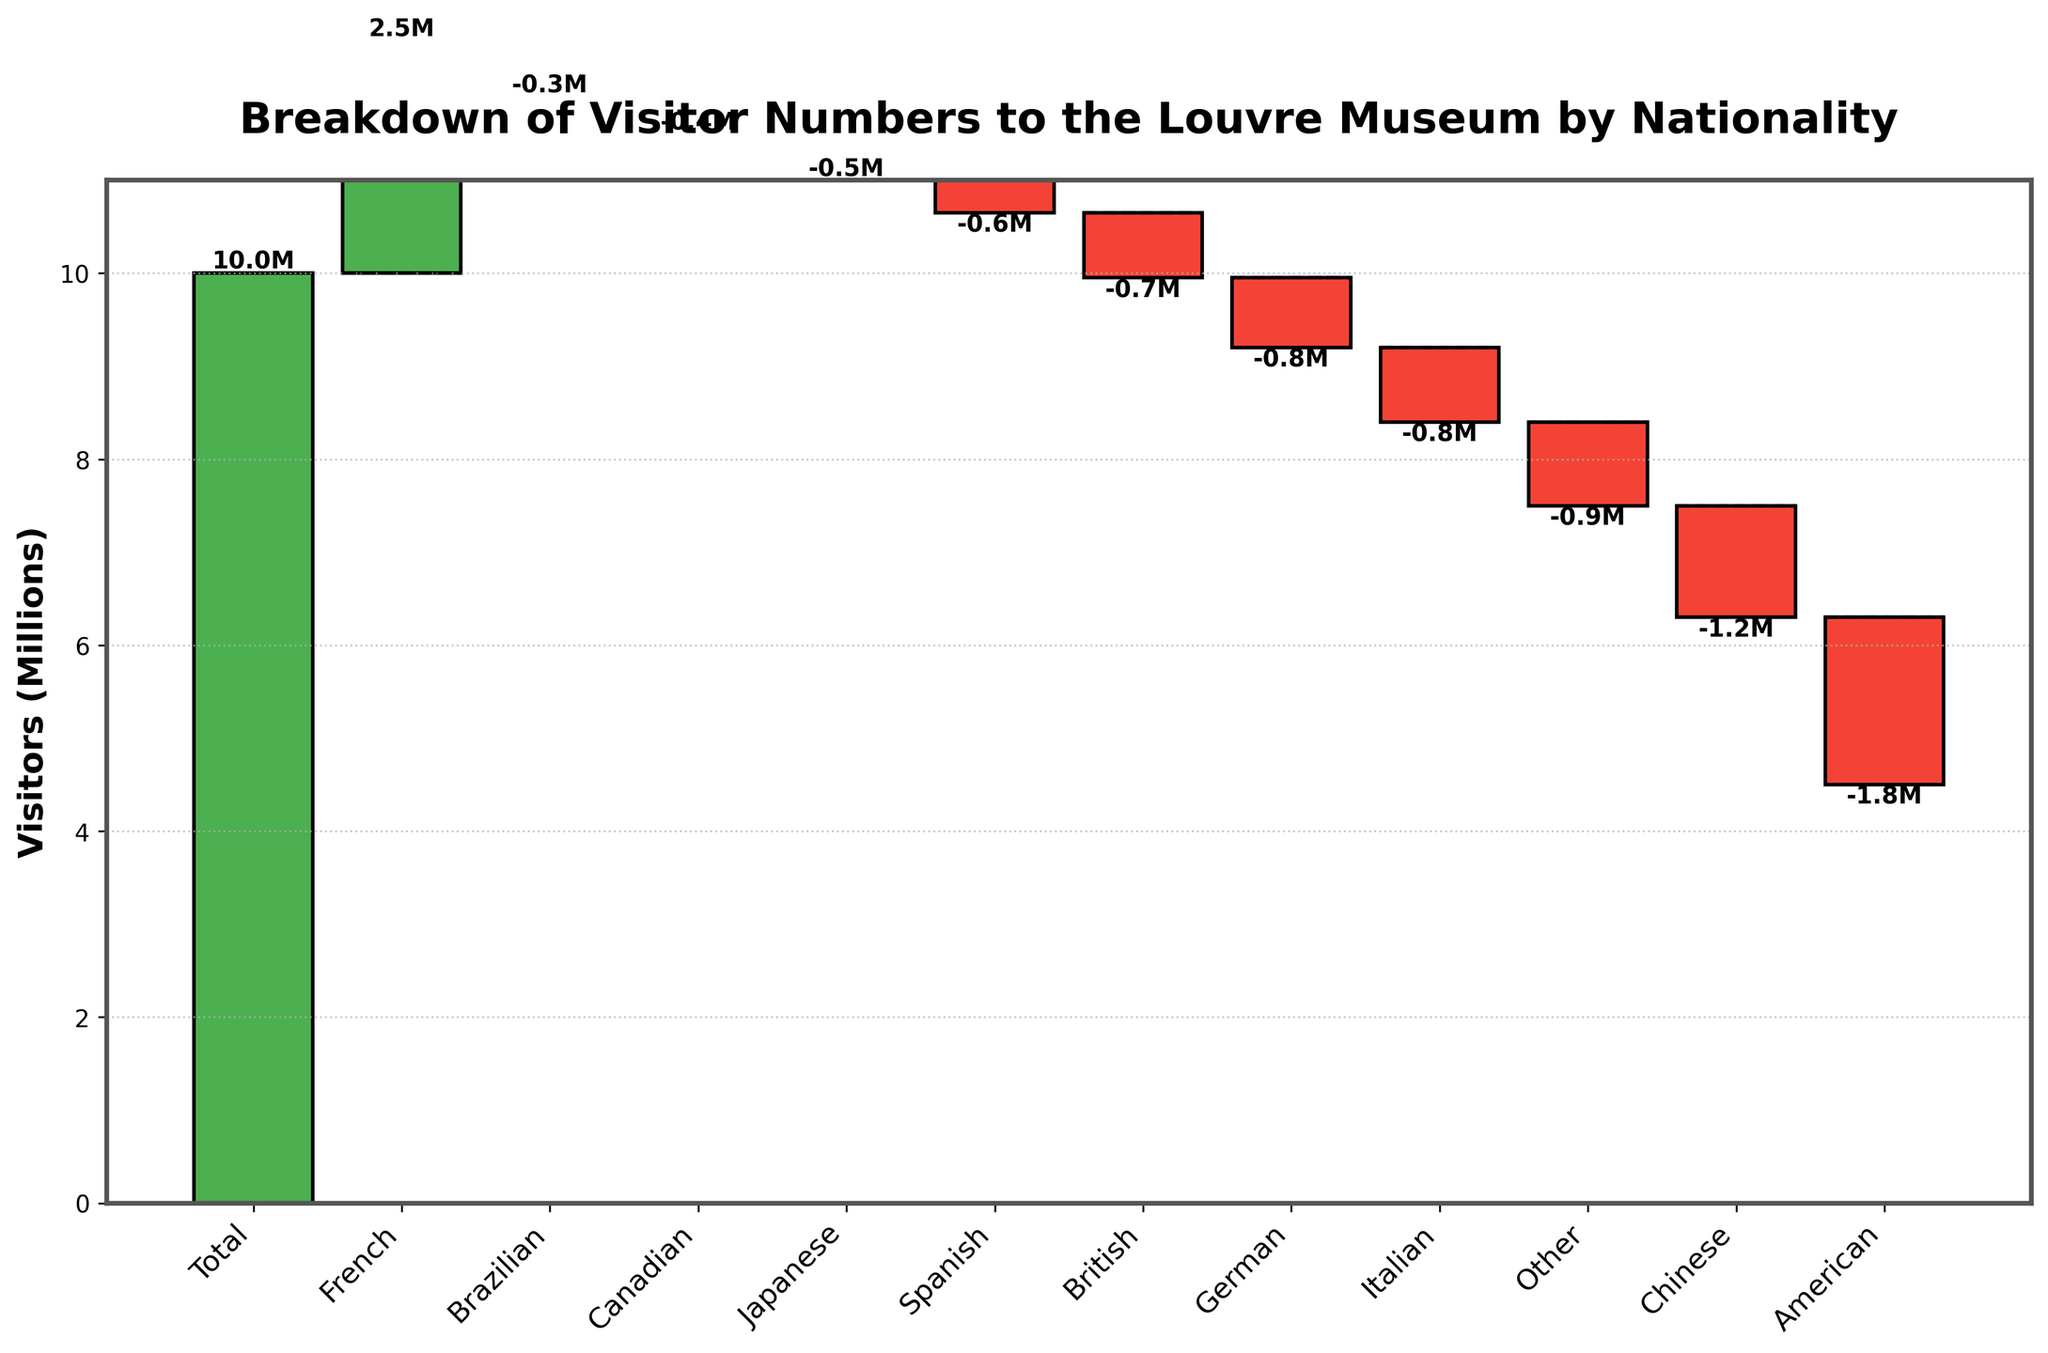What is the title of the figure? The title of the figure is typically found at the top of the chart. The chart's title is "Breakdown of Visitor Numbers to the Louvre Museum by Nationality".
Answer: Breakdown of Visitor Numbers to the Louvre Museum by Nationality How many nationalities are represented in the figure? Each bar in the waterfall chart represents a different nationality. Count the number of bars (excluding the "Total" bar). There are 11 bars corresponding to different nationalities.
Answer: 11 Which nationality contributed the most visitors to the Louvre? To find the nationality that contributed the most visitors, look for the tallest green bar (positive visitors). The "French" nationality has the highest positive value.
Answer: French Which nationality has the least number of visitors to the Louvre? To identify the nationality with the least visitors, look for the smallest red bar (negative visitors). The "Brazilian" nationality has the smallest negative value.
Answer: Brazilian What is the visitor number for Chinese visitors to the Louvre? Locate the "Chinese" label on the x-axis and refer to the height of the corresponding red bar. The value is -1,200,000 visitors.
Answer: -1,200,000 Which two nationalities have similar visitor numbers, and how do their values compare? Compare the heights and values of the bars. The "Italian" and "German" nationalities have similar visitor numbers, with -800,000 for Italians and -750,000 for Germans.
Answer: Italian: -800,000, German: -750,000 What is the cumulative number of visitors after adding the German visitors? Add the visitors from all the previous nationalities before and including the "German" nationality. Total is 10,000,000 + 2,500,000 - 1,800,000 - 1,200,000 - 800,000 - 750,000 = 7,950,000
Answer: 7,950,000 How does the number of British visitors compare to Canadian visitors? Compare the values of the bars labeled "British" and "Canadian". The "British" visitors are -700,000, which is more than the "Canadian" visitors, who are -400,000.
Answer: British visitors: -700,000, Canadian visitors: -400,000 What is the average number of visitors per nationality (excluding 'Total')? Exclude the "Total" and average the visitor numbers of the remaining nationalities. (-1,800,000 + -1,200,000 + -800,000 + -750,000 + -700,000 + -600,000 + -500,000 + -400,000 + -350,000 + -900,000) / 10 = -700,000
Answer: -700,000 What is the difference in visitor numbers between American and Japanese visitors? Find the values for both nationalities and calculate the difference. American visitors are -1,800,000, and Japanese visitors are -500,000; the difference is -1,800,000 - (-500,000) = -1,300,000
Answer: -1,300,000 